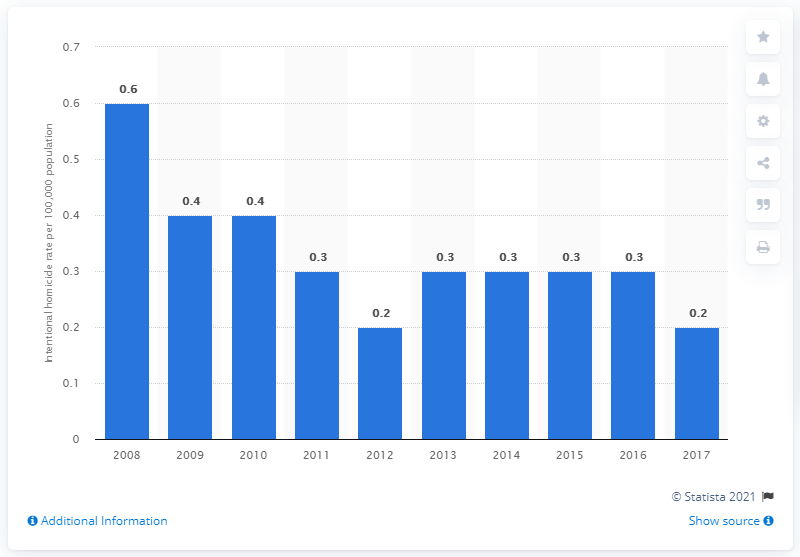Give some essential details in this illustration. According to the data from 2017, the intentional homicide rate in Singapore was 0.2, which indicates a very low level of intentional homicides in the country. 